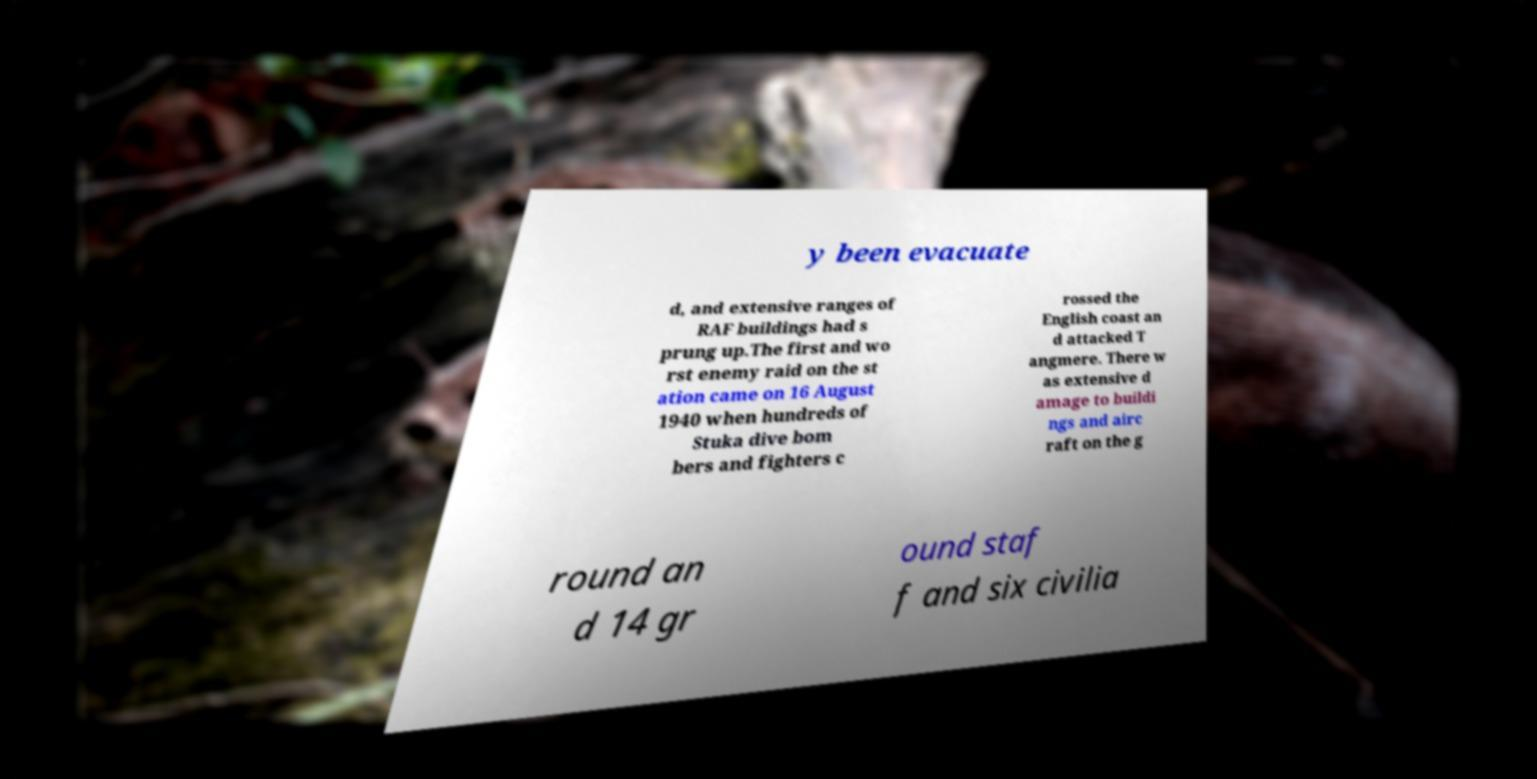There's text embedded in this image that I need extracted. Can you transcribe it verbatim? y been evacuate d, and extensive ranges of RAF buildings had s prung up.The first and wo rst enemy raid on the st ation came on 16 August 1940 when hundreds of Stuka dive bom bers and fighters c rossed the English coast an d attacked T angmere. There w as extensive d amage to buildi ngs and airc raft on the g round an d 14 gr ound staf f and six civilia 